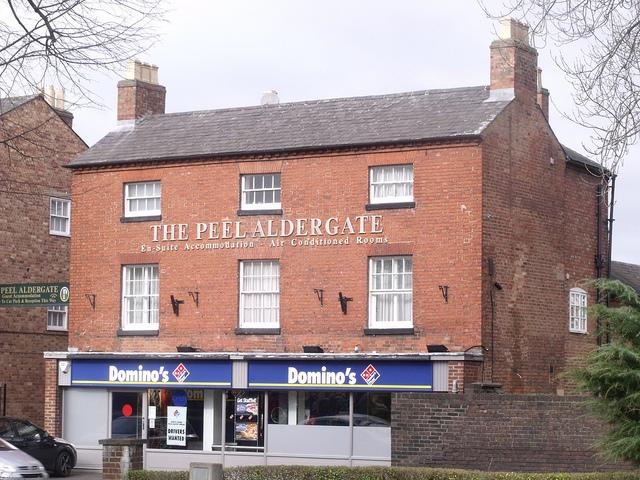What pizza place is on the main level? Please explain your reasoning. domino's. The place is domino's. 